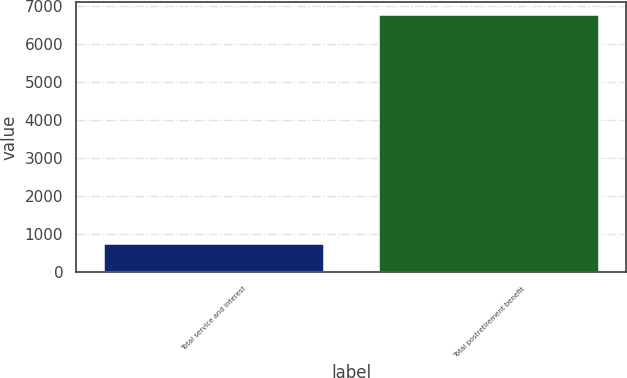Convert chart. <chart><loc_0><loc_0><loc_500><loc_500><bar_chart><fcel>Total service and interest<fcel>Total postretirement benefit<nl><fcel>733<fcel>6766<nl></chart> 